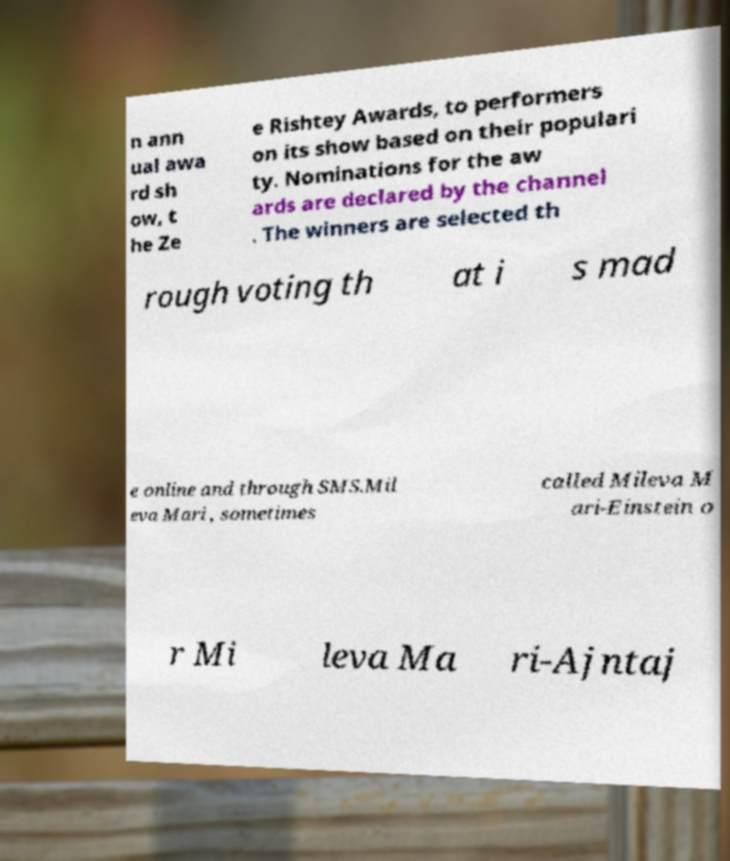For documentation purposes, I need the text within this image transcribed. Could you provide that? n ann ual awa rd sh ow, t he Ze e Rishtey Awards, to performers on its show based on their populari ty. Nominations for the aw ards are declared by the channel . The winners are selected th rough voting th at i s mad e online and through SMS.Mil eva Mari , sometimes called Mileva M ari-Einstein o r Mi leva Ma ri-Ajntaj 